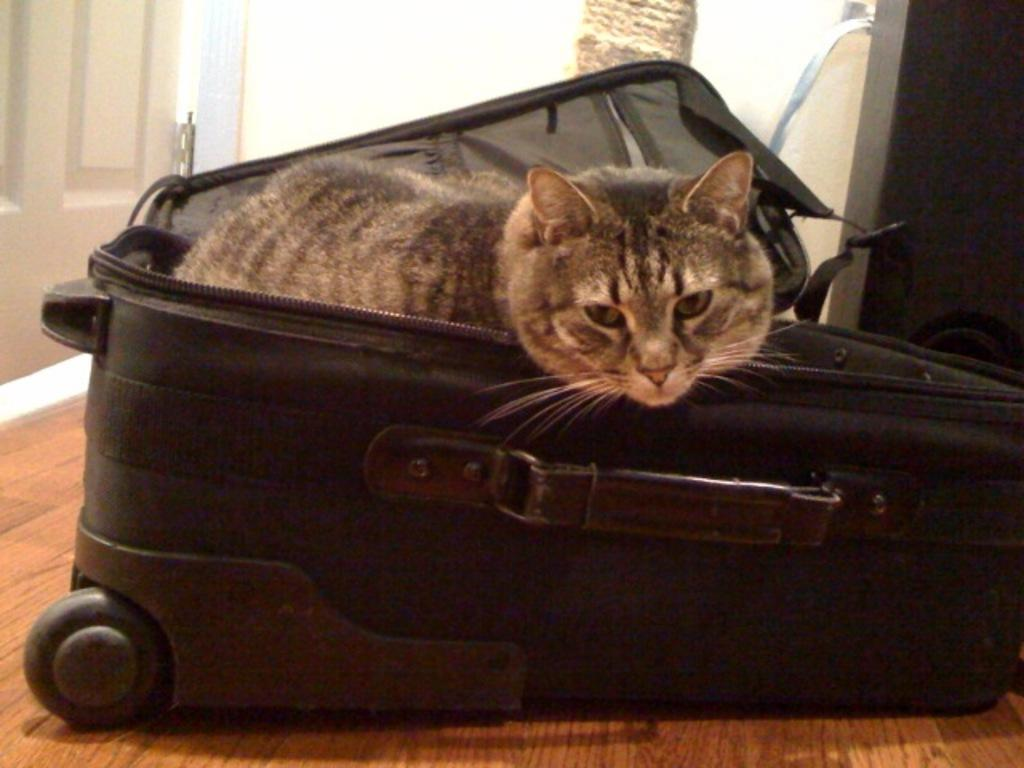What type of animal is in the image? There is a cat in the image. Where is the cat located? The cat is sitting inside a black luggage. What is the position of the luggage in the image? The luggage is on the floor. What can be seen in the background of the image? There is a door visible in the image. What type of work is the maid doing in the image? There is no maid present in the image, so it is not possible to answer that question. 